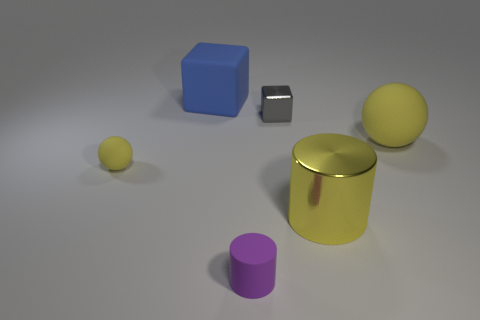Add 3 blue matte objects. How many objects exist? 9 Subtract 1 cylinders. How many cylinders are left? 1 Subtract all blue cubes. How many cubes are left? 1 Subtract all blocks. How many objects are left? 4 Subtract all purple blocks. Subtract all brown spheres. How many blocks are left? 2 Subtract all red balls. How many yellow cubes are left? 0 Subtract all big blue cubes. Subtract all yellow rubber things. How many objects are left? 3 Add 2 yellow metal things. How many yellow metal things are left? 3 Add 6 small yellow matte spheres. How many small yellow matte spheres exist? 7 Subtract 0 green cubes. How many objects are left? 6 